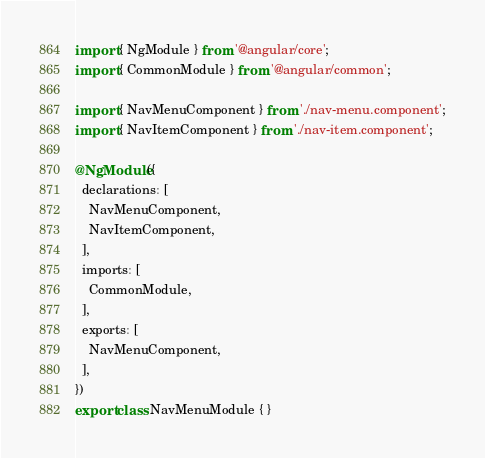Convert code to text. <code><loc_0><loc_0><loc_500><loc_500><_TypeScript_>import { NgModule } from '@angular/core';
import { CommonModule } from '@angular/common';

import { NavMenuComponent } from './nav-menu.component';
import { NavItemComponent } from './nav-item.component';

@NgModule({
  declarations: [
    NavMenuComponent,
    NavItemComponent,
  ],
  imports: [
    CommonModule,
  ],
  exports: [
    NavMenuComponent,
  ],
})
export class NavMenuModule { }
</code> 